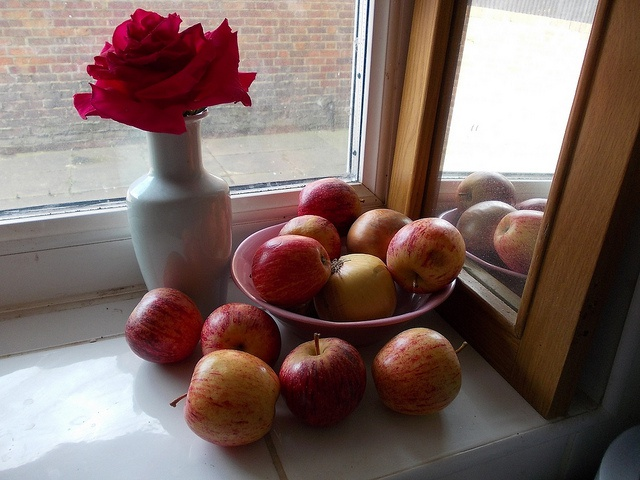Describe the objects in this image and their specific colors. I can see bowl in darkgray, maroon, black, brown, and lightpink tones, apple in darkgray, maroon, black, brown, and lightpink tones, vase in darkgray, maroon, gray, and black tones, apple in darkgray, maroon, brown, and black tones, and apple in darkgray, black, maroon, and brown tones in this image. 